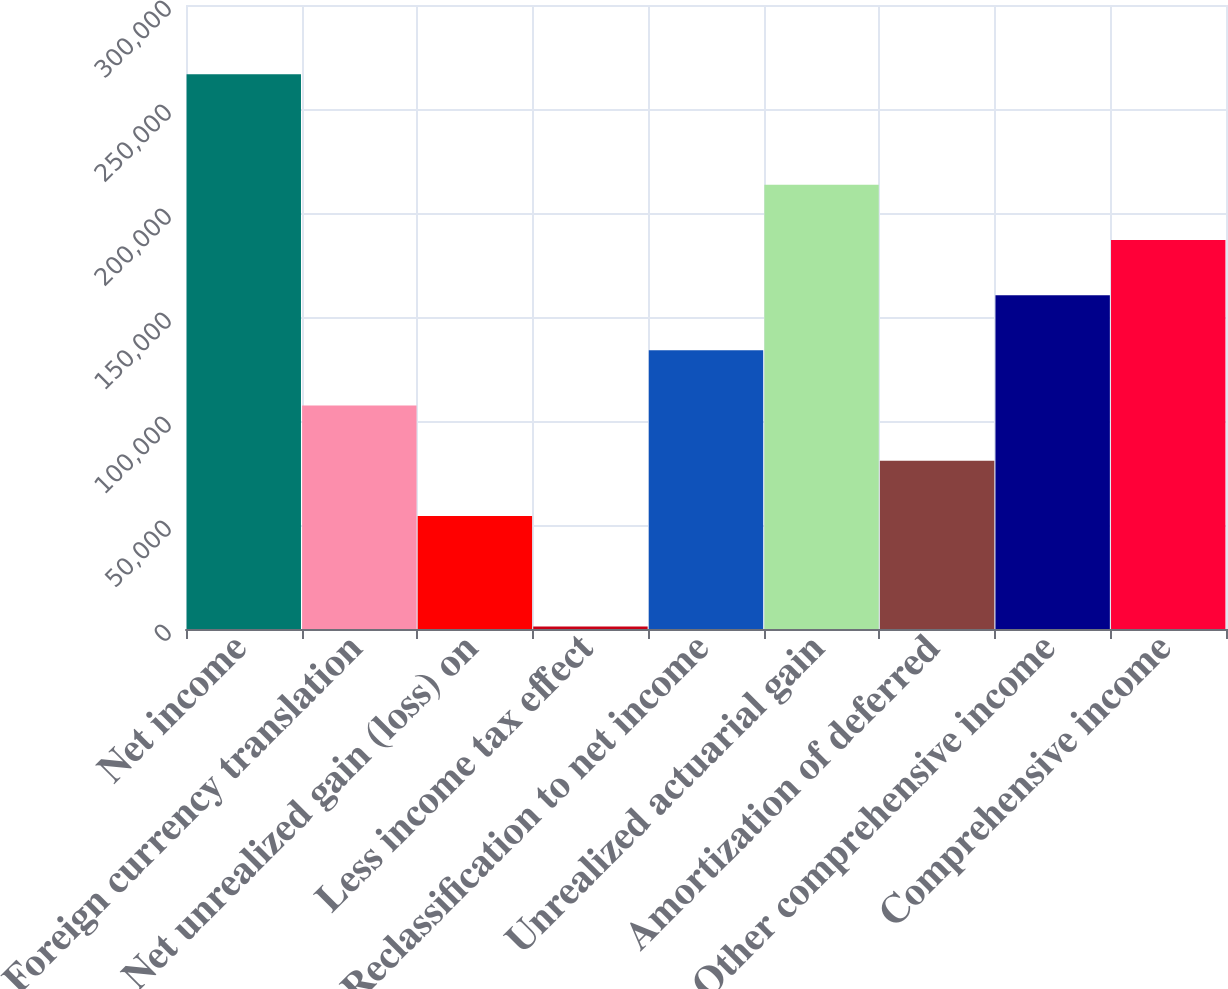Convert chart. <chart><loc_0><loc_0><loc_500><loc_500><bar_chart><fcel>Net income<fcel>Foreign currency translation<fcel>Net unrealized gain (loss) on<fcel>Less income tax effect<fcel>Reclassification to net income<fcel>Unrealized actuarial gain<fcel>Amortization of deferred<fcel>Other comprehensive income<fcel>Comprehensive income<nl><fcel>266688<fcel>107429<fcel>54343.2<fcel>1257<fcel>133972<fcel>213602<fcel>80886.3<fcel>160516<fcel>187059<nl></chart> 